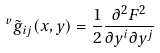Convert formula to latex. <formula><loc_0><loc_0><loc_500><loc_500>\ ^ { v } { \tilde { g } } _ { i j } ( x , y ) = \frac { 1 } { 2 } \frac { \partial ^ { 2 } F ^ { 2 } } { \partial y ^ { i } \partial y ^ { j } }</formula> 